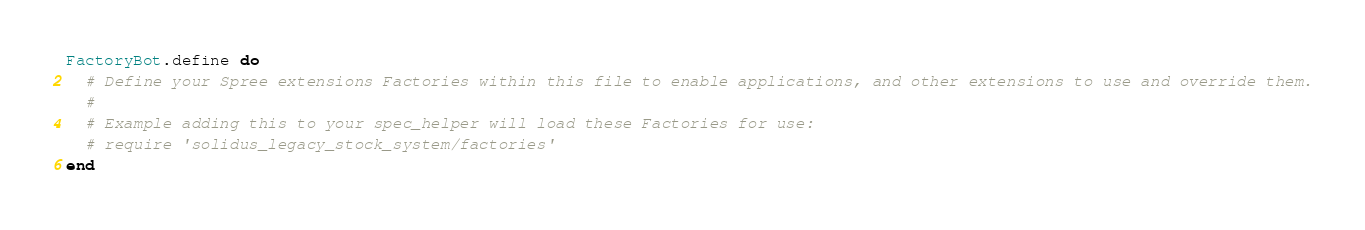Convert code to text. <code><loc_0><loc_0><loc_500><loc_500><_Ruby_>FactoryBot.define do
  # Define your Spree extensions Factories within this file to enable applications, and other extensions to use and override them.
  #
  # Example adding this to your spec_helper will load these Factories for use:
  # require 'solidus_legacy_stock_system/factories'
end
</code> 